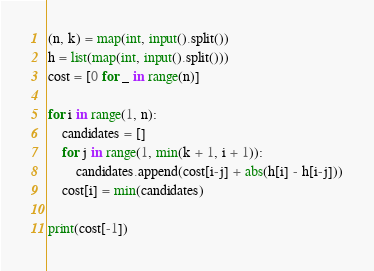Convert code to text. <code><loc_0><loc_0><loc_500><loc_500><_Python_>(n, k) = map(int, input().split())
h = list(map(int, input().split()))
cost = [0 for _ in range(n)]

for i in range(1, n):
    candidates = []
    for j in range(1, min(k + 1, i + 1)):
        candidates.append(cost[i-j] + abs(h[i] - h[i-j]))
    cost[i] = min(candidates)

print(cost[-1])
</code> 